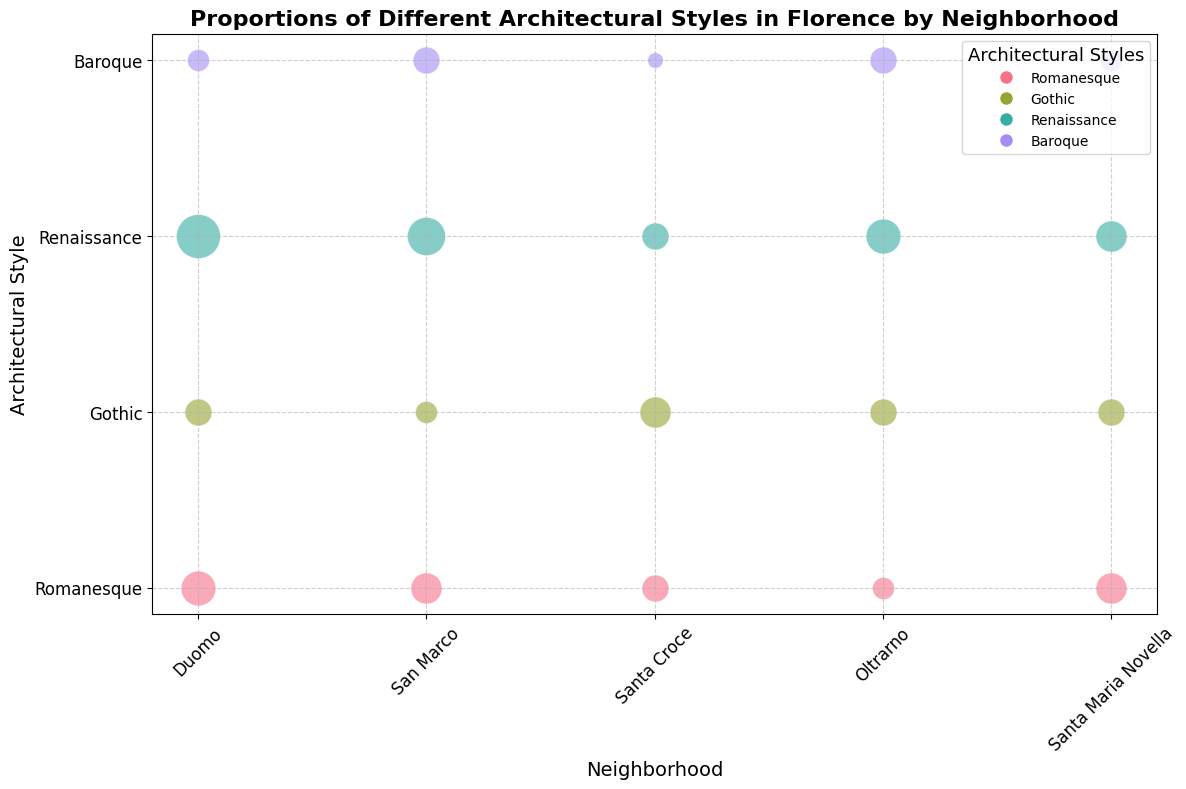Which neighborhood has the most Renaissance structures? By examining the bubble sizes in the figure for the Renaissance style across different neighborhoods, we can identify the neighborhood with the largest bubble for this style.
Answer: Duomo How many Gothic structures are there in Duomo and how does that compare to San Marco? To find this, look at the bubble sizes for the Gothic style in Duomo and San Marco. The bubble in Duomo represents 3 structures, while the one in San Marco represents 2. Thus, Duomo has one more Gothic structure than San Marco.
Answer: Duomo has 1 more than San Marco Which architectural style is least represented in Santa Croce? By examining the bubble sizes in Santa Croce for each style, we see that the smallest bubble represents the Baroque style, indicating this is the least common.
Answer: Baroque Which neighborhood has the highest number of unique notable structures for the Romanesque style? Compare the notable structures listed in the Romanesque bubbles for each neighborhood. Duomo lists Santa Maria del Fiore and Baptistery of San Giovanni (2 structures), and other neighborhoods list either 1 or 2 as well. Hence, no neighborhood has more unique notable structures for Romanesque.
Answer: None has more What is the combined count of architectural structures in Oltrarno? Add the counts of Romanesque (2), Gothic (3), Renaissance (5), and Baroque (3) structures in Oltrarno. The total is 2 + 3 + 5 + 3 = 13 structures.
Answer: 13 Which style dominates across all neighborhoods? To determine the dominant style, compare the bubble sizes for all styles across all neighborhoods. Renaissance has the largest combined bubble size, indicating it is the dominant style.
Answer: Renaissance How does the number of structures in Santa Maria Novella compare to those in San Marco for the Romanesque style? Look at the bubble sizes for the Romanesque style in both Santa Maria Novella and San Marco. Both neighborhoods have 4 structures each. Thus, the number of structures is equal.
Answer: Equal What neighborhood has the smallest count of notable structures for a single architectural style? By matching the neighborhoods and their notable structures, Santa Croce has only 1 notable structure for the Baroque style, which is the smallest count for any neighborhood-style combination.
Answer: Santa Croce for Baroque Comparing Duomo and Santa Croce, which neighborhood has more notable Gothic structures? By checking the notable structures listed in the Gothic bubbles, Duomo has two notable structures (Orsanmichele, Bargello), while Santa Croce has one (Santa Croce Basilica). Thus, Duomo has more notable Gothic structures.
Answer: Duomo 